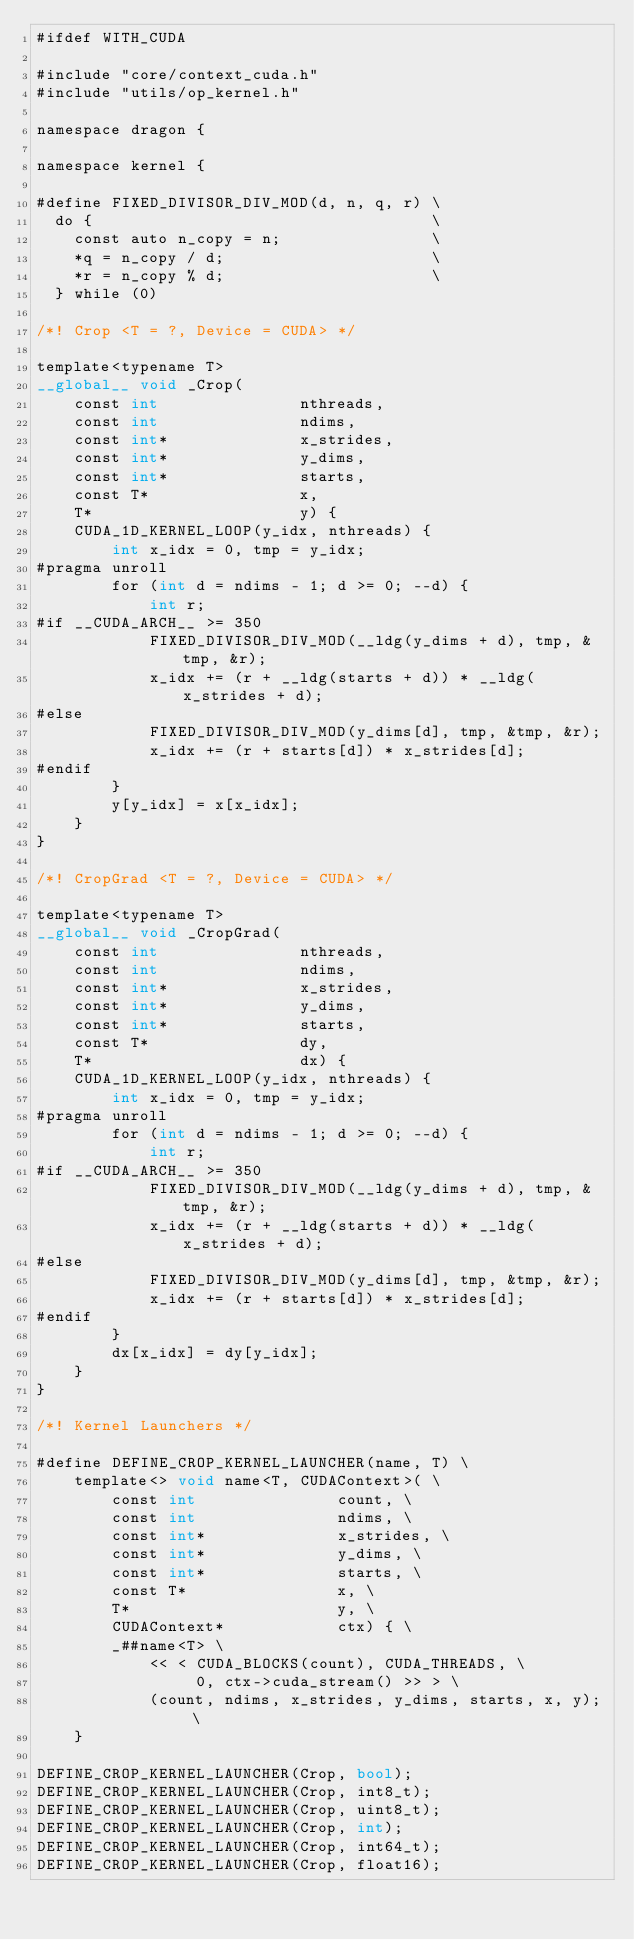<code> <loc_0><loc_0><loc_500><loc_500><_Cuda_>#ifdef WITH_CUDA

#include "core/context_cuda.h"
#include "utils/op_kernel.h"

namespace dragon {

namespace kernel {

#define FIXED_DIVISOR_DIV_MOD(d, n, q, r) \
  do {                                    \
    const auto n_copy = n;                \
    *q = n_copy / d;                      \
    *r = n_copy % d;                      \
  } while (0)

/*! Crop <T = ?, Device = CUDA> */

template<typename T>
__global__ void _Crop(
    const int               nthreads,
    const int               ndims,
    const int*              x_strides,
    const int*              y_dims,
    const int*              starts,
    const T*                x,
    T*                      y) {
    CUDA_1D_KERNEL_LOOP(y_idx, nthreads) {
        int x_idx = 0, tmp = y_idx;
#pragma unroll
        for (int d = ndims - 1; d >= 0; --d) {
            int r;
#if __CUDA_ARCH__ >= 350
            FIXED_DIVISOR_DIV_MOD(__ldg(y_dims + d), tmp, &tmp, &r);
            x_idx += (r + __ldg(starts + d)) * __ldg(x_strides + d);
#else
            FIXED_DIVISOR_DIV_MOD(y_dims[d], tmp, &tmp, &r);
            x_idx += (r + starts[d]) * x_strides[d];
#endif
        }
        y[y_idx] = x[x_idx];
    }
}

/*! CropGrad <T = ?, Device = CUDA> */

template<typename T>
__global__ void _CropGrad(
    const int               nthreads,
    const int               ndims,
    const int*              x_strides,
    const int*              y_dims,
    const int*              starts,
    const T*                dy,
    T*                      dx) {
    CUDA_1D_KERNEL_LOOP(y_idx, nthreads) {
        int x_idx = 0, tmp = y_idx;
#pragma unroll
        for (int d = ndims - 1; d >= 0; --d) {
            int r;
#if __CUDA_ARCH__ >= 350
            FIXED_DIVISOR_DIV_MOD(__ldg(y_dims + d), tmp, &tmp, &r);
            x_idx += (r + __ldg(starts + d)) * __ldg(x_strides + d);
#else
            FIXED_DIVISOR_DIV_MOD(y_dims[d], tmp, &tmp, &r);
            x_idx += (r + starts[d]) * x_strides[d];
#endif
        }
        dx[x_idx] = dy[y_idx];
    }
}

/*! Kernel Launchers */

#define DEFINE_CROP_KERNEL_LAUNCHER(name, T) \
    template<> void name<T, CUDAContext>( \
        const int               count, \
        const int               ndims, \
        const int*              x_strides, \
        const int*              y_dims, \
        const int*              starts, \
        const T*                x, \
        T*                      y, \
        CUDAContext*            ctx) { \
        _##name<T> \
            << < CUDA_BLOCKS(count), CUDA_THREADS, \
                 0, ctx->cuda_stream() >> > \
            (count, ndims, x_strides, y_dims, starts, x, y); \
    }

DEFINE_CROP_KERNEL_LAUNCHER(Crop, bool);
DEFINE_CROP_KERNEL_LAUNCHER(Crop, int8_t);
DEFINE_CROP_KERNEL_LAUNCHER(Crop, uint8_t);
DEFINE_CROP_KERNEL_LAUNCHER(Crop, int);
DEFINE_CROP_KERNEL_LAUNCHER(Crop, int64_t);
DEFINE_CROP_KERNEL_LAUNCHER(Crop, float16);</code> 